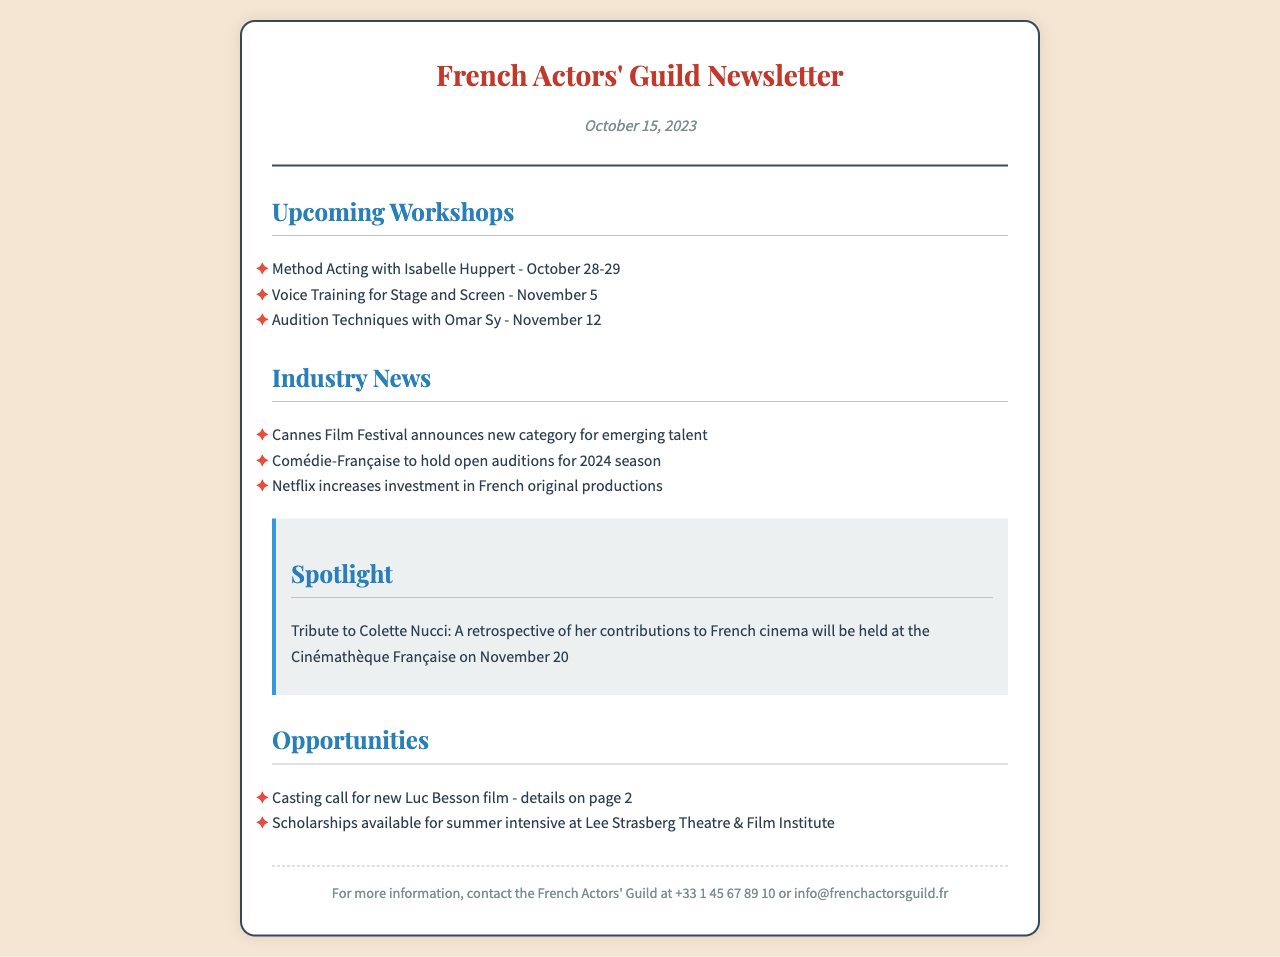What is the date of the newsletter? The date is explicitly mentioned in the document header.
Answer: October 15, 2023 Who is conducting the Method Acting workshop? The newsletter specifies the instructor for the workshop.
Answer: Isabelle Huppert What is the date of the audition techniques workshop? The document lists the exact date for this specific workshop.
Answer: November 12 What notable film festival is mentioned in the industry news? The document highlights a specific film festival in its news section.
Answer: Cannes Film Festival What tribute is being held on November 20? The spotlight section of the newsletter describes an event related to a prominent figure.
Answer: Tribute to Colette Nucci How many workshops are listed in the upcoming section? The number of workshops can be counted directly from the list in the document.
Answer: Three What organization is holding open auditions for the 2024 season? The document provides the name of the theater associated with the auditions.
Answer: Comédie-Française What type of scholarship is mentioned in the opportunities section? The opportunities section refers to a specific type of educational aid.
Answer: Scholarships for summer intensive at Lee Strasberg Theatre & Film Institute 